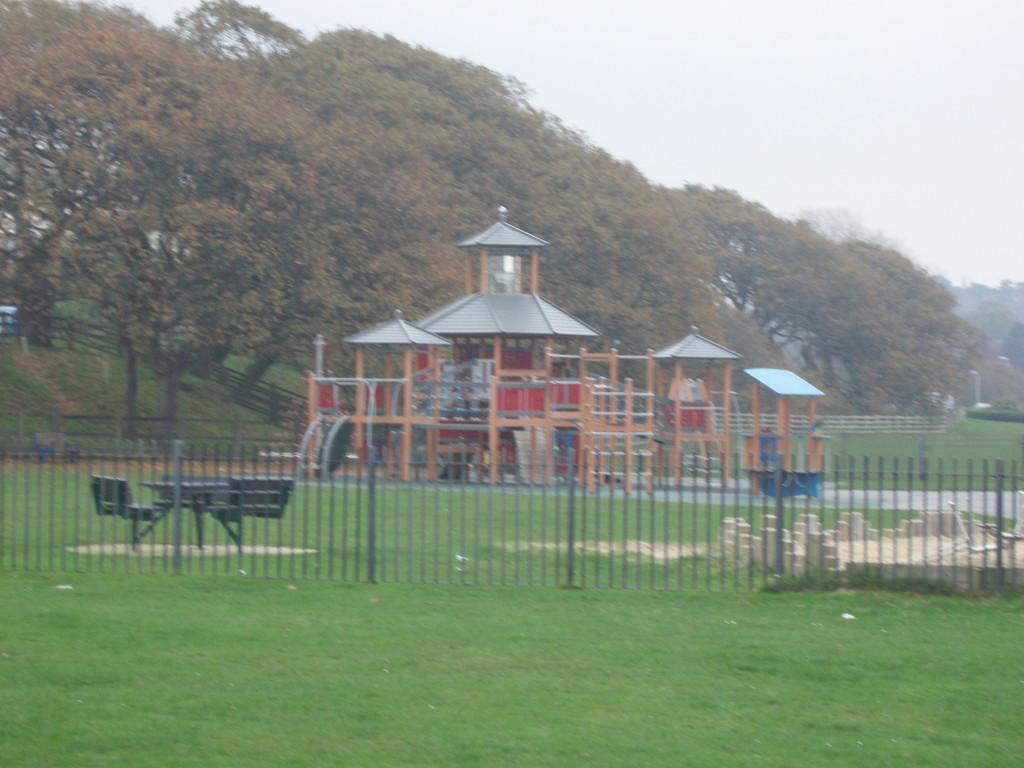Can you describe this image briefly? In the foreground of this picture, there is a railing and grass. In the background, there are chairs, tables, a gaming house, trees and the sky. 